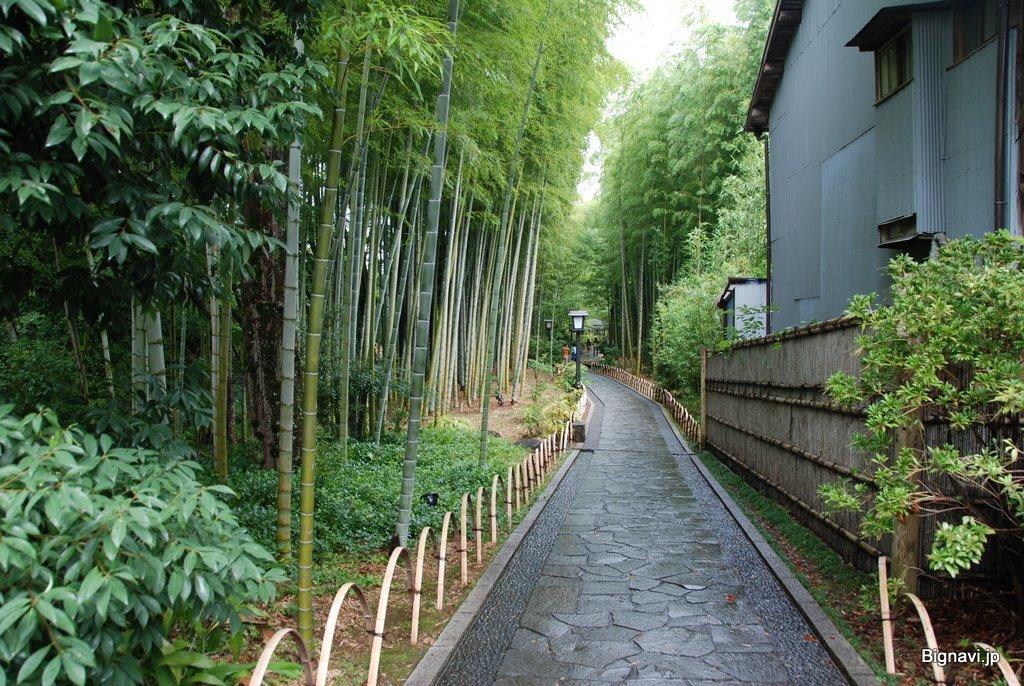Describe this image in one or two sentences. In this image, we can see so many trees, plants, grass, railings, fencing, house, poles with light. Here we can see a walkway. 